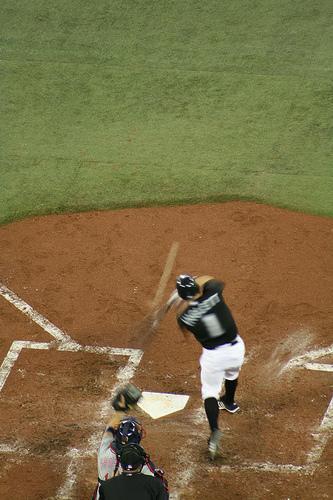How many people are there?
Give a very brief answer. 3. 